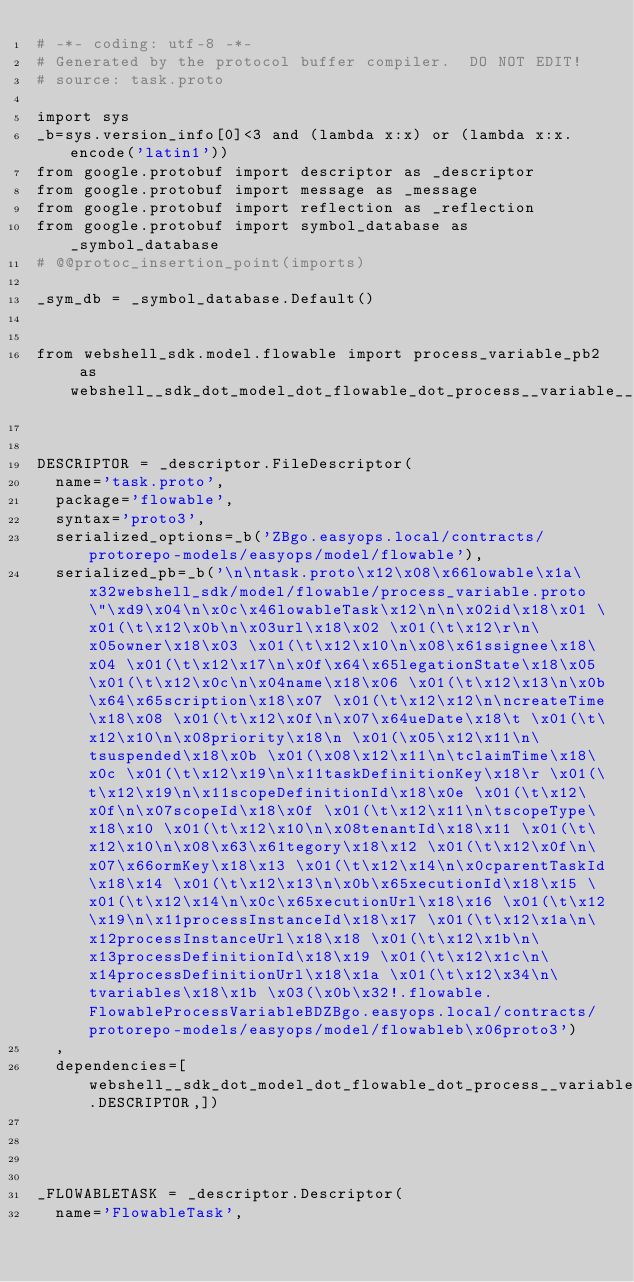<code> <loc_0><loc_0><loc_500><loc_500><_Python_># -*- coding: utf-8 -*-
# Generated by the protocol buffer compiler.  DO NOT EDIT!
# source: task.proto

import sys
_b=sys.version_info[0]<3 and (lambda x:x) or (lambda x:x.encode('latin1'))
from google.protobuf import descriptor as _descriptor
from google.protobuf import message as _message
from google.protobuf import reflection as _reflection
from google.protobuf import symbol_database as _symbol_database
# @@protoc_insertion_point(imports)

_sym_db = _symbol_database.Default()


from webshell_sdk.model.flowable import process_variable_pb2 as webshell__sdk_dot_model_dot_flowable_dot_process__variable__pb2


DESCRIPTOR = _descriptor.FileDescriptor(
  name='task.proto',
  package='flowable',
  syntax='proto3',
  serialized_options=_b('ZBgo.easyops.local/contracts/protorepo-models/easyops/model/flowable'),
  serialized_pb=_b('\n\ntask.proto\x12\x08\x66lowable\x1a\x32webshell_sdk/model/flowable/process_variable.proto\"\xd9\x04\n\x0c\x46lowableTask\x12\n\n\x02id\x18\x01 \x01(\t\x12\x0b\n\x03url\x18\x02 \x01(\t\x12\r\n\x05owner\x18\x03 \x01(\t\x12\x10\n\x08\x61ssignee\x18\x04 \x01(\t\x12\x17\n\x0f\x64\x65legationState\x18\x05 \x01(\t\x12\x0c\n\x04name\x18\x06 \x01(\t\x12\x13\n\x0b\x64\x65scription\x18\x07 \x01(\t\x12\x12\n\ncreateTime\x18\x08 \x01(\t\x12\x0f\n\x07\x64ueDate\x18\t \x01(\t\x12\x10\n\x08priority\x18\n \x01(\x05\x12\x11\n\tsuspended\x18\x0b \x01(\x08\x12\x11\n\tclaimTime\x18\x0c \x01(\t\x12\x19\n\x11taskDefinitionKey\x18\r \x01(\t\x12\x19\n\x11scopeDefinitionId\x18\x0e \x01(\t\x12\x0f\n\x07scopeId\x18\x0f \x01(\t\x12\x11\n\tscopeType\x18\x10 \x01(\t\x12\x10\n\x08tenantId\x18\x11 \x01(\t\x12\x10\n\x08\x63\x61tegory\x18\x12 \x01(\t\x12\x0f\n\x07\x66ormKey\x18\x13 \x01(\t\x12\x14\n\x0cparentTaskId\x18\x14 \x01(\t\x12\x13\n\x0b\x65xecutionId\x18\x15 \x01(\t\x12\x14\n\x0c\x65xecutionUrl\x18\x16 \x01(\t\x12\x19\n\x11processInstanceId\x18\x17 \x01(\t\x12\x1a\n\x12processInstanceUrl\x18\x18 \x01(\t\x12\x1b\n\x13processDefinitionId\x18\x19 \x01(\t\x12\x1c\n\x14processDefinitionUrl\x18\x1a \x01(\t\x12\x34\n\tvariables\x18\x1b \x03(\x0b\x32!.flowable.FlowableProcessVariableBDZBgo.easyops.local/contracts/protorepo-models/easyops/model/flowableb\x06proto3')
  ,
  dependencies=[webshell__sdk_dot_model_dot_flowable_dot_process__variable__pb2.DESCRIPTOR,])




_FLOWABLETASK = _descriptor.Descriptor(
  name='FlowableTask',</code> 